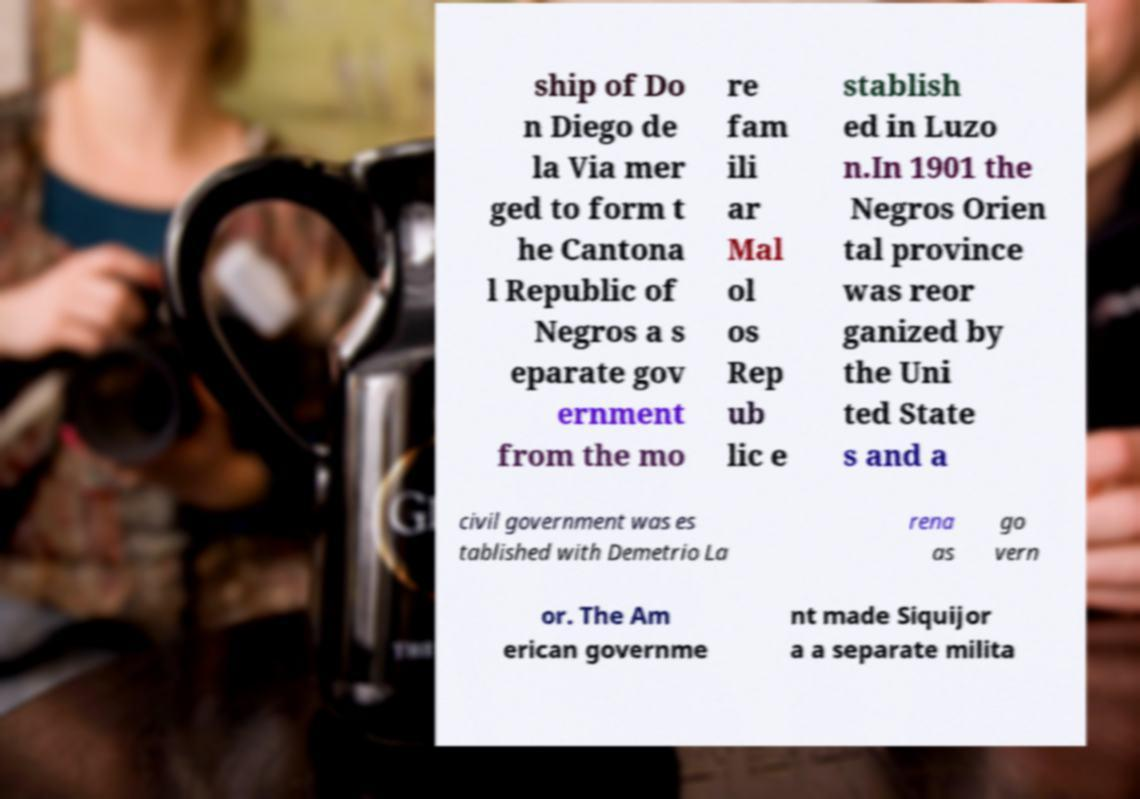Could you assist in decoding the text presented in this image and type it out clearly? ship of Do n Diego de la Via mer ged to form t he Cantona l Republic of Negros a s eparate gov ernment from the mo re fam ili ar Mal ol os Rep ub lic e stablish ed in Luzo n.In 1901 the Negros Orien tal province was reor ganized by the Uni ted State s and a civil government was es tablished with Demetrio La rena as go vern or. The Am erican governme nt made Siquijor a a separate milita 